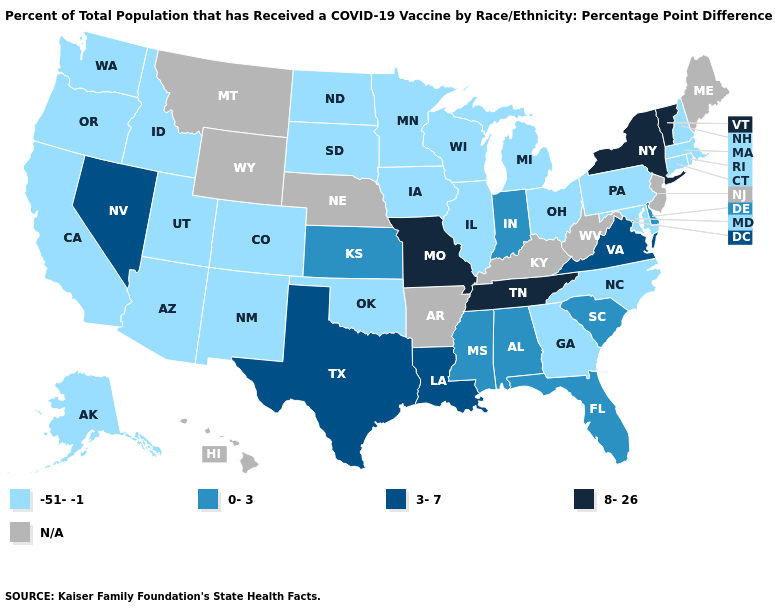What is the value of New Hampshire?
Quick response, please. -51--1. Does the map have missing data?
Short answer required. Yes. Does the map have missing data?
Answer briefly. Yes. Does Tennessee have the highest value in the USA?
Answer briefly. Yes. Name the states that have a value in the range -51--1?
Be succinct. Alaska, Arizona, California, Colorado, Connecticut, Georgia, Idaho, Illinois, Iowa, Maryland, Massachusetts, Michigan, Minnesota, New Hampshire, New Mexico, North Carolina, North Dakota, Ohio, Oklahoma, Oregon, Pennsylvania, Rhode Island, South Dakota, Utah, Washington, Wisconsin. Among the states that border Wisconsin , which have the highest value?
Give a very brief answer. Illinois, Iowa, Michigan, Minnesota. What is the value of New Hampshire?
Give a very brief answer. -51--1. What is the lowest value in states that border Wyoming?
Short answer required. -51--1. Name the states that have a value in the range N/A?
Concise answer only. Arkansas, Hawaii, Kentucky, Maine, Montana, Nebraska, New Jersey, West Virginia, Wyoming. What is the value of New Hampshire?
Answer briefly. -51--1. Which states have the highest value in the USA?
Be succinct. Missouri, New York, Tennessee, Vermont. How many symbols are there in the legend?
Be succinct. 5. Does Missouri have the highest value in the USA?
Be succinct. Yes. 